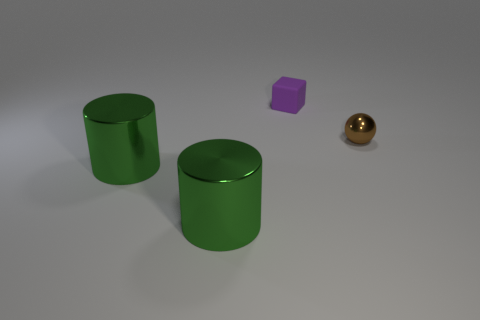Add 2 tiny blocks. How many objects exist? 6 Subtract all blocks. How many objects are left? 3 Subtract all green shiny cylinders. Subtract all small rubber cubes. How many objects are left? 1 Add 2 tiny brown objects. How many tiny brown objects are left? 3 Add 3 small cyan balls. How many small cyan balls exist? 3 Subtract 0 gray blocks. How many objects are left? 4 